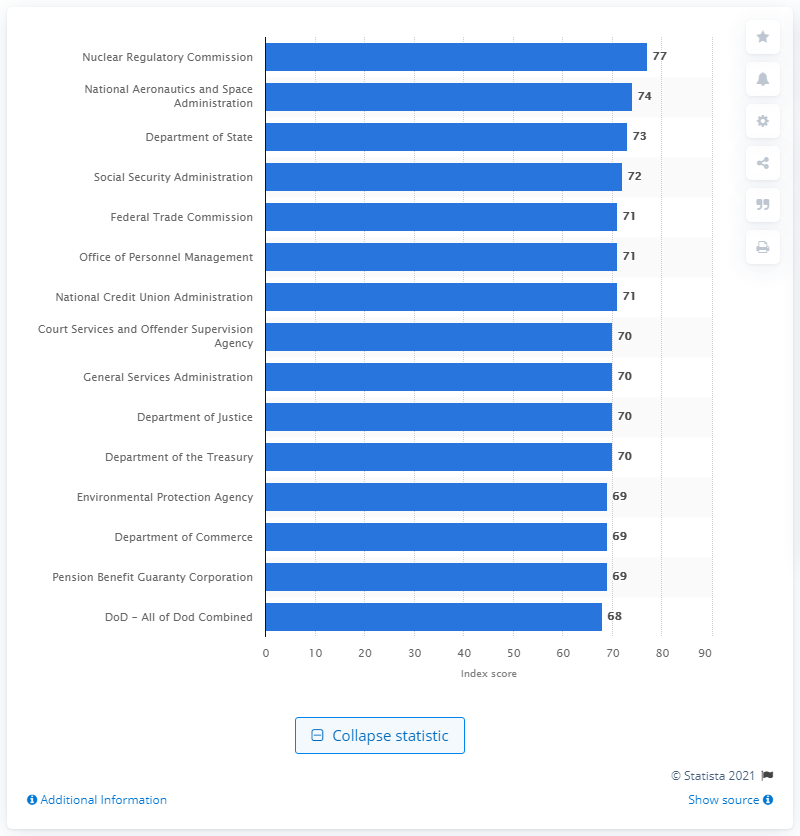Indicate a few pertinent items in this graphic. In the 2011 Federal Employee Viewpoint Survey, the Nuclear Regulatory Commission ranked as the highest-ranking U.S. government agency. 